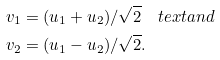Convert formula to latex. <formula><loc_0><loc_0><loc_500><loc_500>v _ { 1 } & = ( u _ { 1 } + u _ { 2 } ) / \sqrt { 2 } \quad t e x t { a n d } \\ v _ { 2 } & = ( u _ { 1 } - u _ { 2 } ) / \sqrt { 2 } .</formula> 